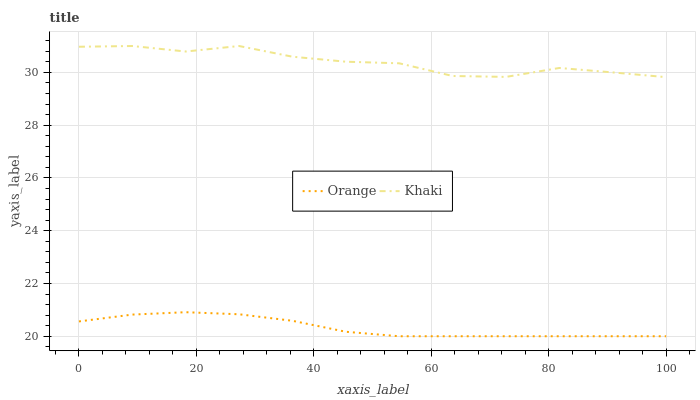Does Khaki have the minimum area under the curve?
Answer yes or no. No. Is Khaki the smoothest?
Answer yes or no. No. Does Khaki have the lowest value?
Answer yes or no. No. Is Orange less than Khaki?
Answer yes or no. Yes. Is Khaki greater than Orange?
Answer yes or no. Yes. Does Orange intersect Khaki?
Answer yes or no. No. 